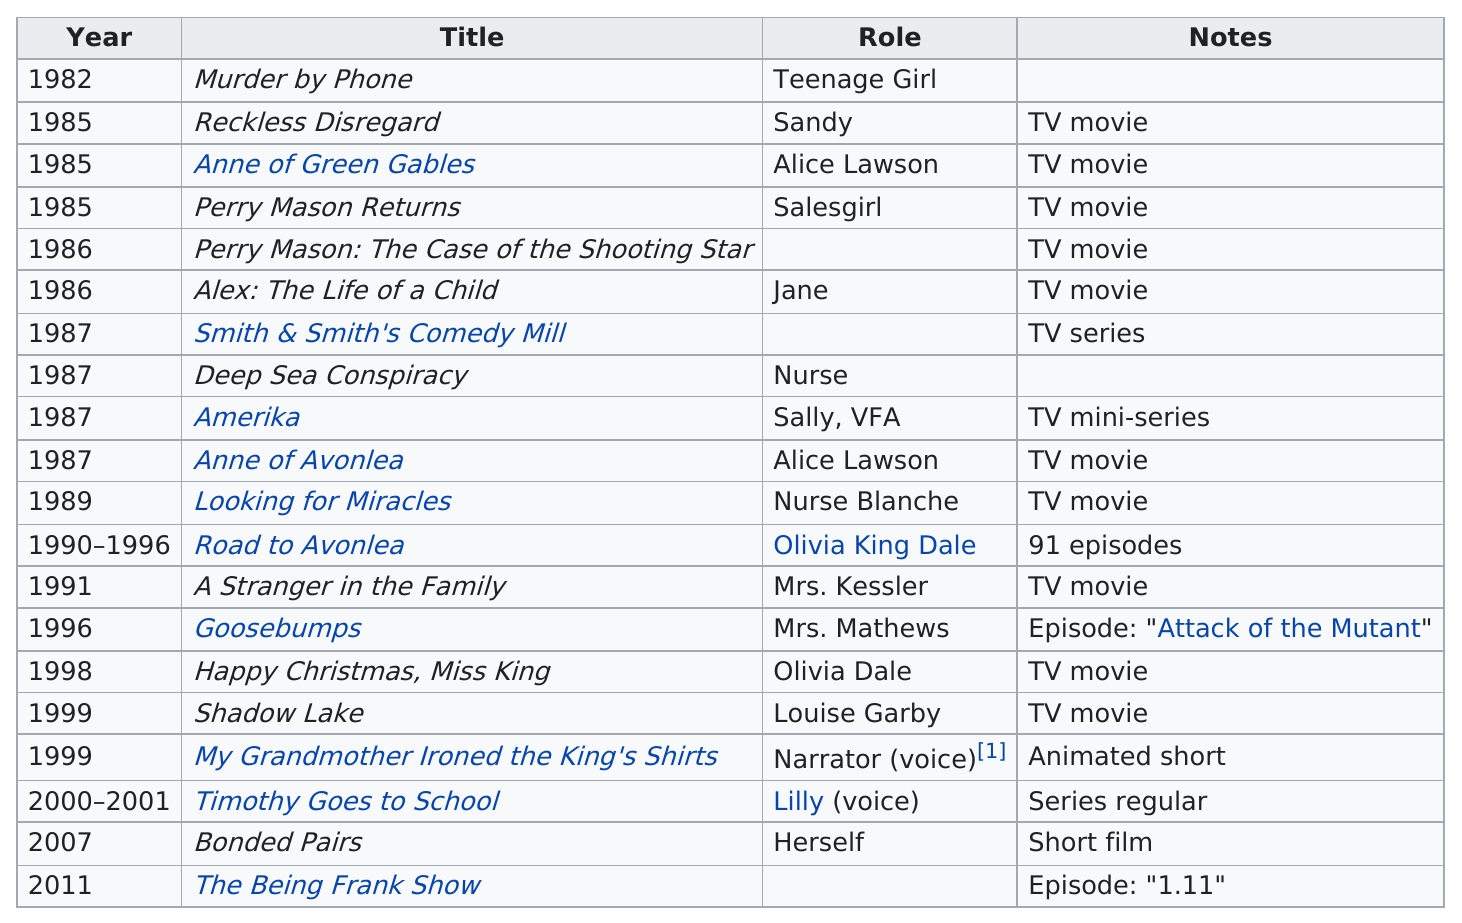Outline some significant characteristics in this image. The television show with the highest number of episodes featuring Mag Ruffman is 'Road to Avonlea.' Mag Ruffman appeared in one TV miniseries. Mag Ruffman's role as Alice Lawson, which she first played in Anne of Green Gables in 1985, was renewed in the movie Anne of Avonlea. Road to Avonlea is a television series that has the longest running time among all series. 